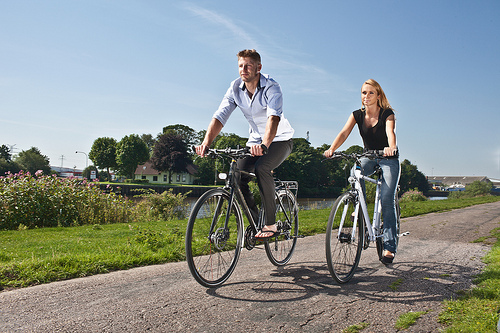<image>
Is there a women to the left of the men? Yes. From this viewpoint, the women is positioned to the left side relative to the men. 